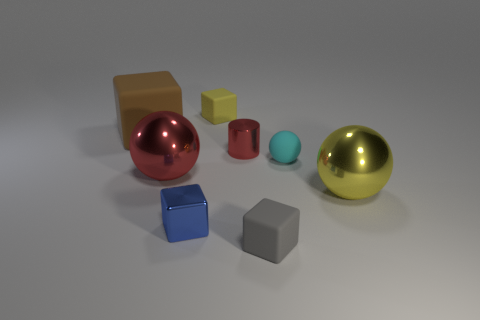Subtract all blue cubes. How many cubes are left? 3 Add 2 small yellow rubber objects. How many objects exist? 10 Subtract all red blocks. Subtract all blue cylinders. How many blocks are left? 4 Subtract all cylinders. How many objects are left? 7 Add 6 brown matte things. How many brown matte things are left? 7 Add 6 small spheres. How many small spheres exist? 7 Subtract 0 cyan cylinders. How many objects are left? 8 Subtract all large purple metallic cylinders. Subtract all shiny objects. How many objects are left? 4 